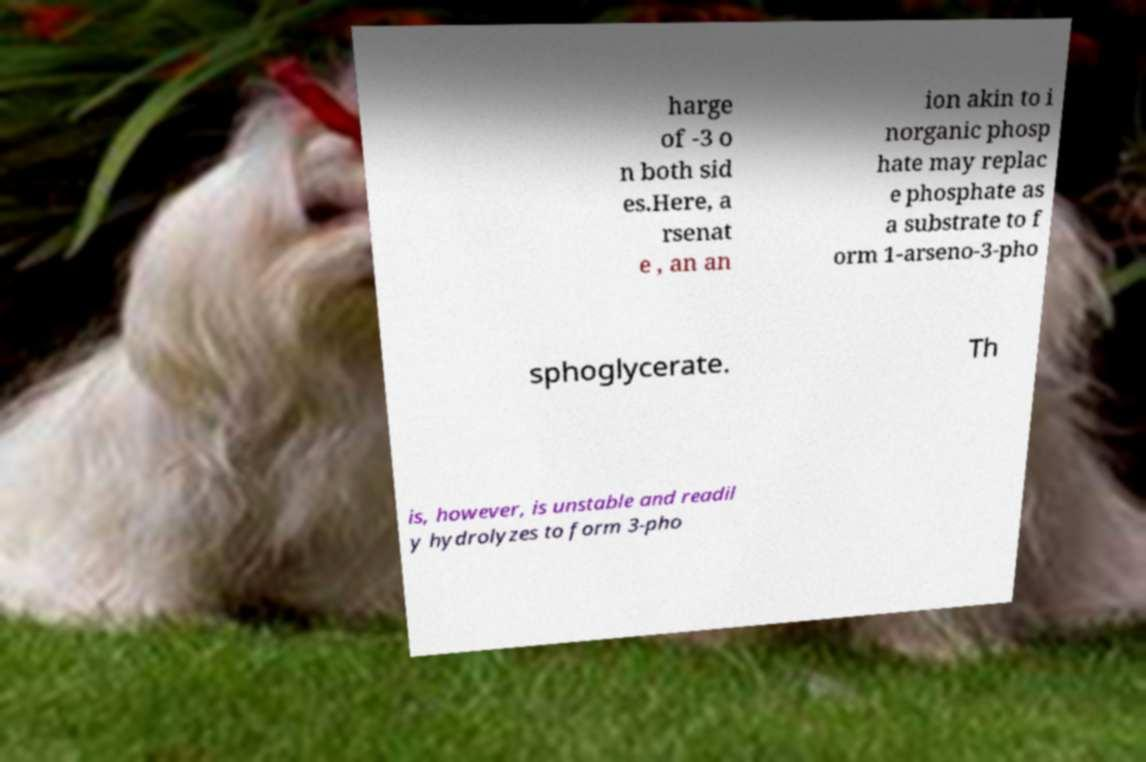Could you assist in decoding the text presented in this image and type it out clearly? harge of -3 o n both sid es.Here, a rsenat e , an an ion akin to i norganic phosp hate may replac e phosphate as a substrate to f orm 1-arseno-3-pho sphoglycerate. Th is, however, is unstable and readil y hydrolyzes to form 3-pho 